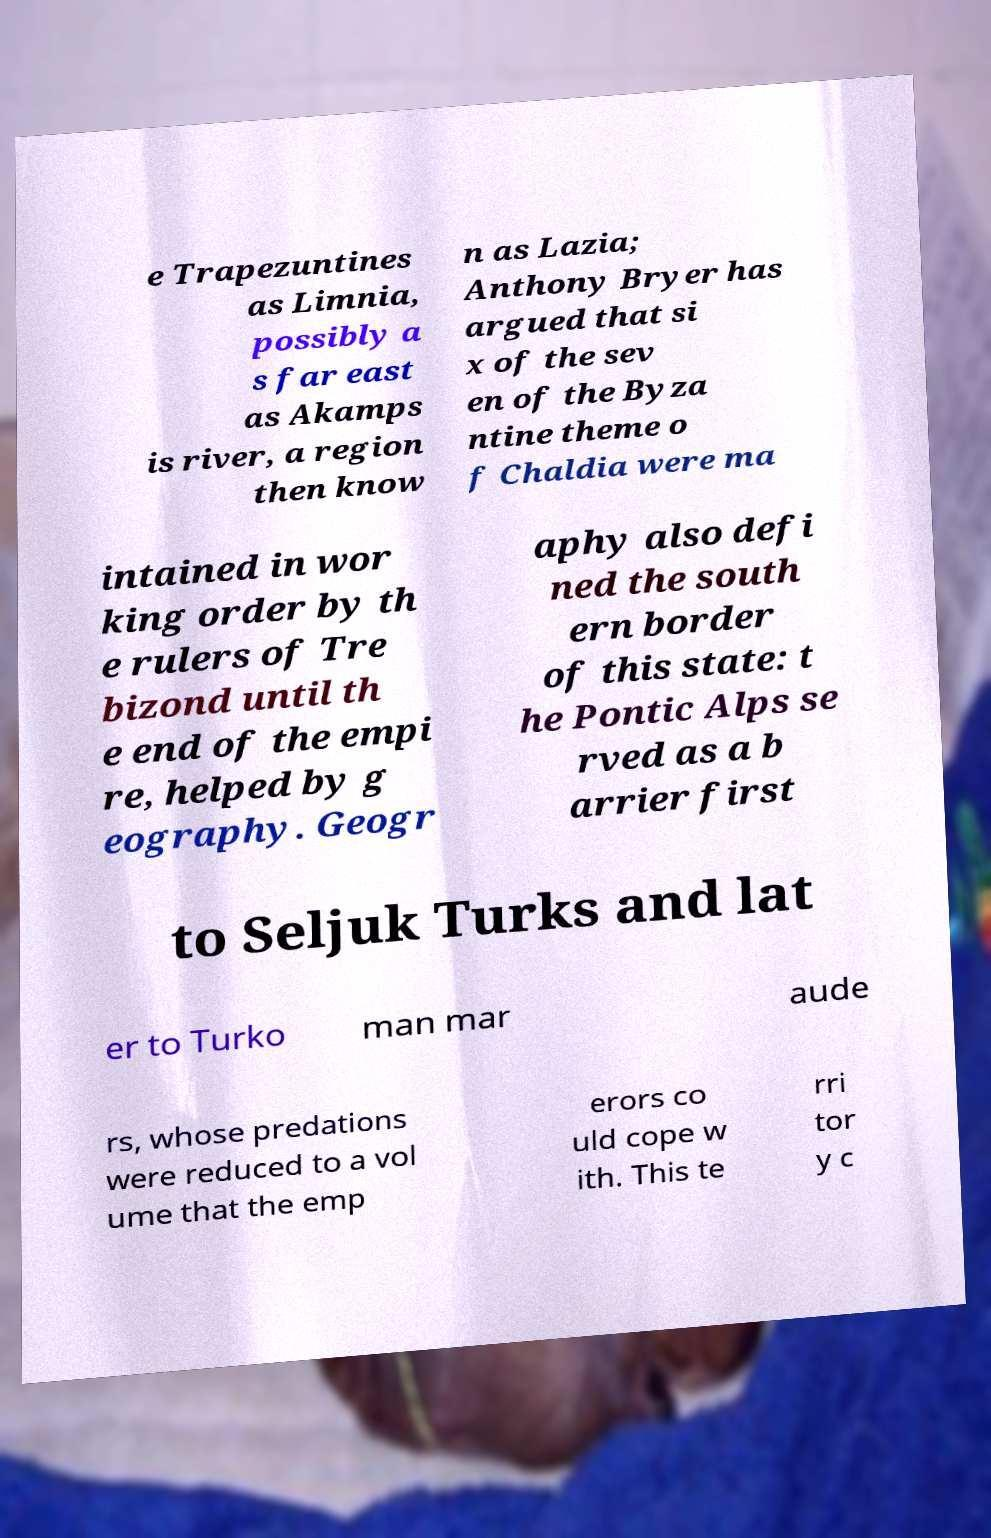Please identify and transcribe the text found in this image. e Trapezuntines as Limnia, possibly a s far east as Akamps is river, a region then know n as Lazia; Anthony Bryer has argued that si x of the sev en of the Byza ntine theme o f Chaldia were ma intained in wor king order by th e rulers of Tre bizond until th e end of the empi re, helped by g eography. Geogr aphy also defi ned the south ern border of this state: t he Pontic Alps se rved as a b arrier first to Seljuk Turks and lat er to Turko man mar aude rs, whose predations were reduced to a vol ume that the emp erors co uld cope w ith. This te rri tor y c 